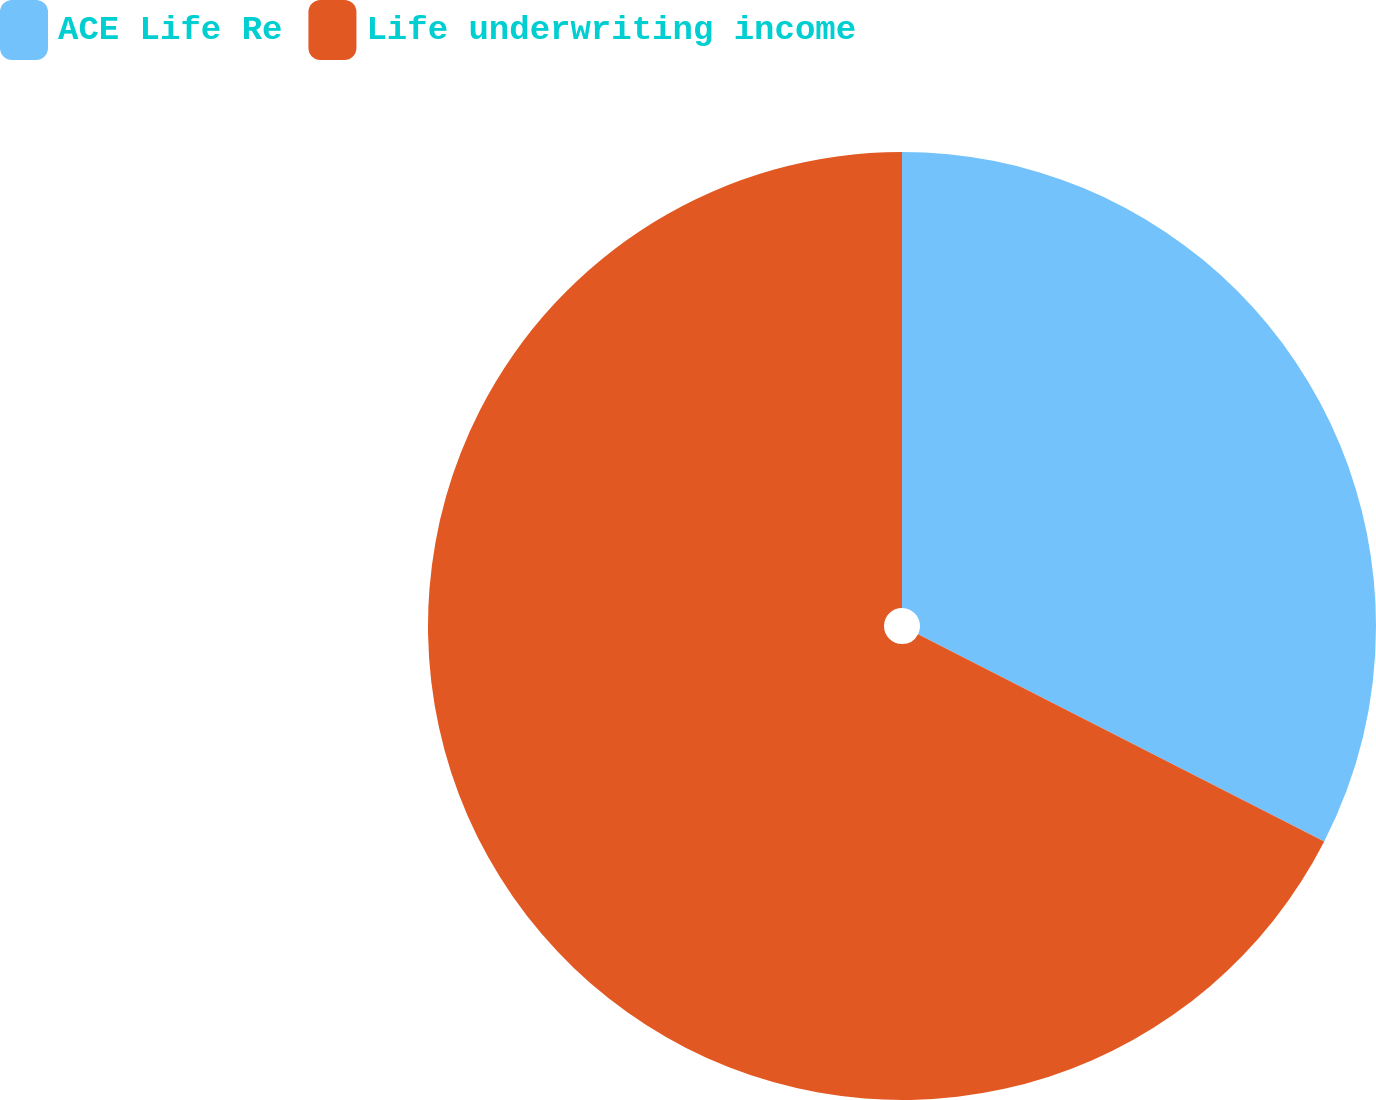Convert chart. <chart><loc_0><loc_0><loc_500><loc_500><pie_chart><fcel>ACE Life Re<fcel>Life underwriting income<nl><fcel>32.51%<fcel>67.49%<nl></chart> 